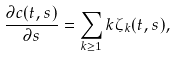Convert formula to latex. <formula><loc_0><loc_0><loc_500><loc_500>\frac { \partial c ( t , s ) } { \partial s } = \sum _ { k \geq 1 } k \zeta _ { k } ( t , s ) ,</formula> 